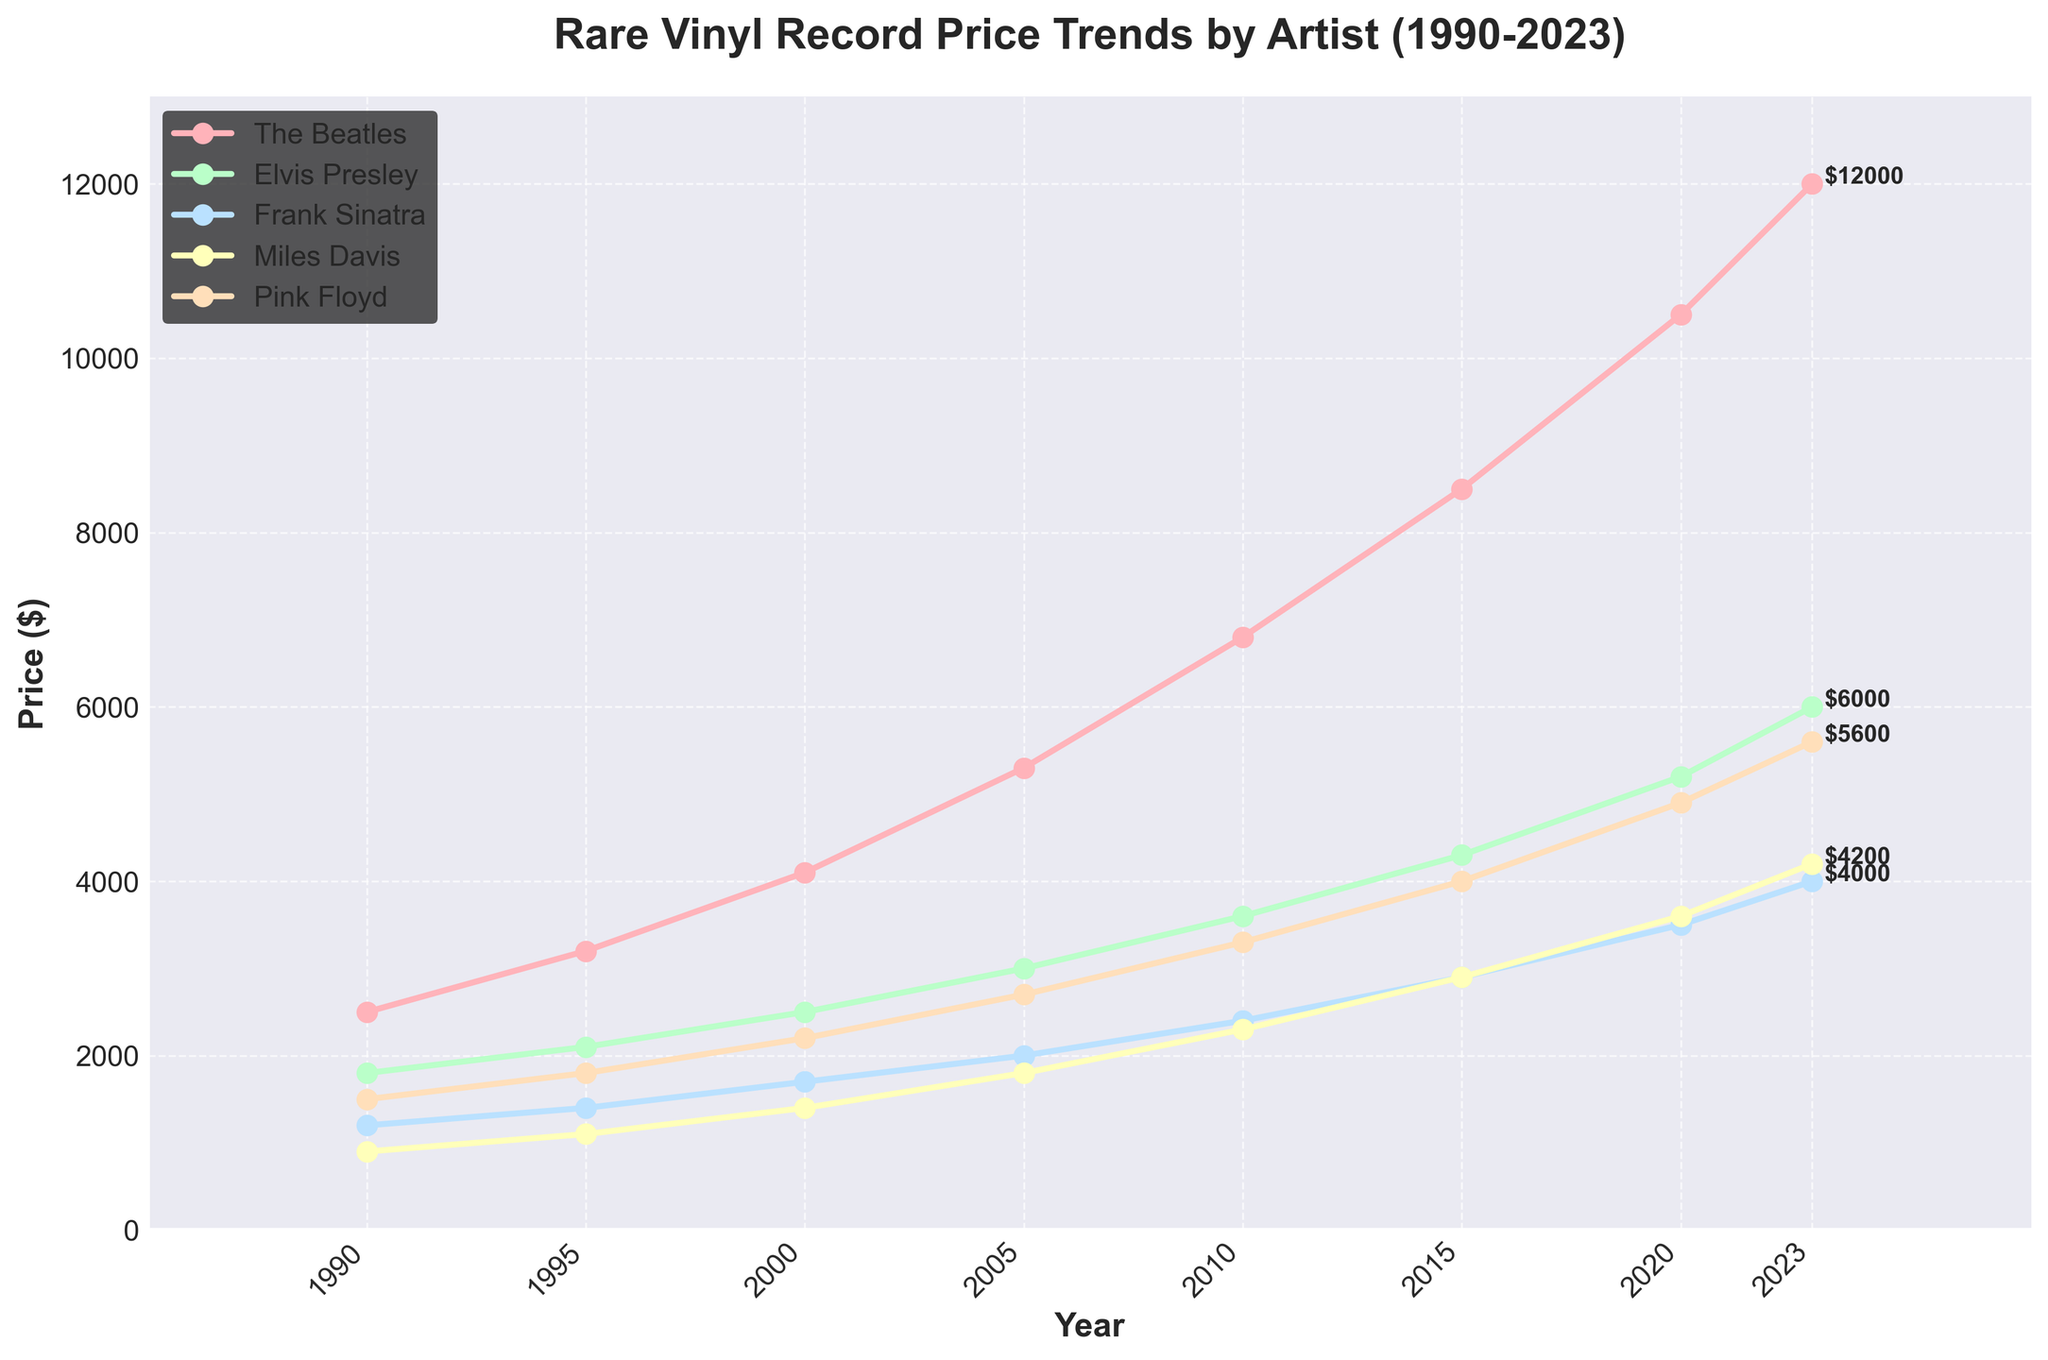Which artist's vinyl records had the highest price in 2023? The highest price in 2023 among the artists listed is for The Beatles at $12,000.
Answer: The Beatles Which artist experienced the highest price increase between 1990 and 2023? To find the artist with the highest price increase, subtract 1990 values from 2023 values for each artist: The Beatles (12000-2500=9500), Elvis Presley (6000-1800=4200), Frank Sinatra (4000-1200=2800), Miles Davis (4200-900=3300), Pink Floyd (5600-1500=4100). The Beatles have the highest increase of $9,500.
Answer: The Beatles What is the average price of Elvis Presley's vinyl records over the entire period? Sum prices for Elvis Presley from 1990 to 2023 and divide by the number of years: (1800+2100+2500+3000+3600+4300+5200+6000)/8. The average price is $3562.5.
Answer: $3562.5 How do the prices of Frank Sinatra's and Miles Davis' records compare in 2010? In 2010, Frank Sinatra's records are priced at $2400 and Miles Davis' at $2300. Frank Sinatra's records are $100 higher than Miles Davis'.
Answer: Frank Sinatra's records are higher Which artist's vinyl records saw the smallest price increase from 1995 to 2010? Subtract the 1995 values from the 2010 values for each artist: The Beatles (6800-3200=3600), Elvis Presley (3600-2100=1500), Frank Sinatra (2400-1400=1000), Miles Davis (2300-1100=1200), Pink Floyd (3300-1800=1500). Frank Sinatra has the smallest increase of $1000.
Answer: Frank Sinatra What is the total sum of prices of all artists' vinyl records in 2000? Add the prices of all artists' records for the year 2000: 4100 (The Beatles) + 2500 (Elvis Presley) + 1700 (Frank Sinatra) + 1400 (Miles Davis) + 2200 (Pink Floyd) = 11900.
Answer: $11900 Which artist's vinyl records had their prices closest to $5000 in 2023? In 2023, compare each artist's record price to $5000: The Beatles ($12000 - $5000 = $7000), Elvis Presley ($6000 - $5000 = $1000), Frank Sinatra ($4000 - $5000 = $1000), Miles Davis ($4200 - $5000 = $800), Pink Floyd ($5600 - $5000 = $600). Pink Floyd's record prices are the closest to $5000.
Answer: Pink Floyd What was the price difference between Elvis Presley and Pink Floyd vinyl records in 2020? Subtract Pink Floyd's price from Elvis Presley's price for 2020: 5200 (Elvis Presley) - 4900 (Pink Floyd) = 300.
Answer: $300 Which artist has the most consistent price increase, judging by the linearity of their trend line? Evaluate the smoothness of the lines of each artist. The Beatles show a relatively more consistent increase when looking at the gradual slope of the trend line compared to others, which have more fluctuations.
Answer: The Beatles What can be said about the trend of Miles Davis' vinyl records from 1990 to 2023? Miles Davis' prices consistently increase from 900 in 1990 to 4200 in 2023, with a steady upward trend signaling growing demand.
Answer: Consistently increased 